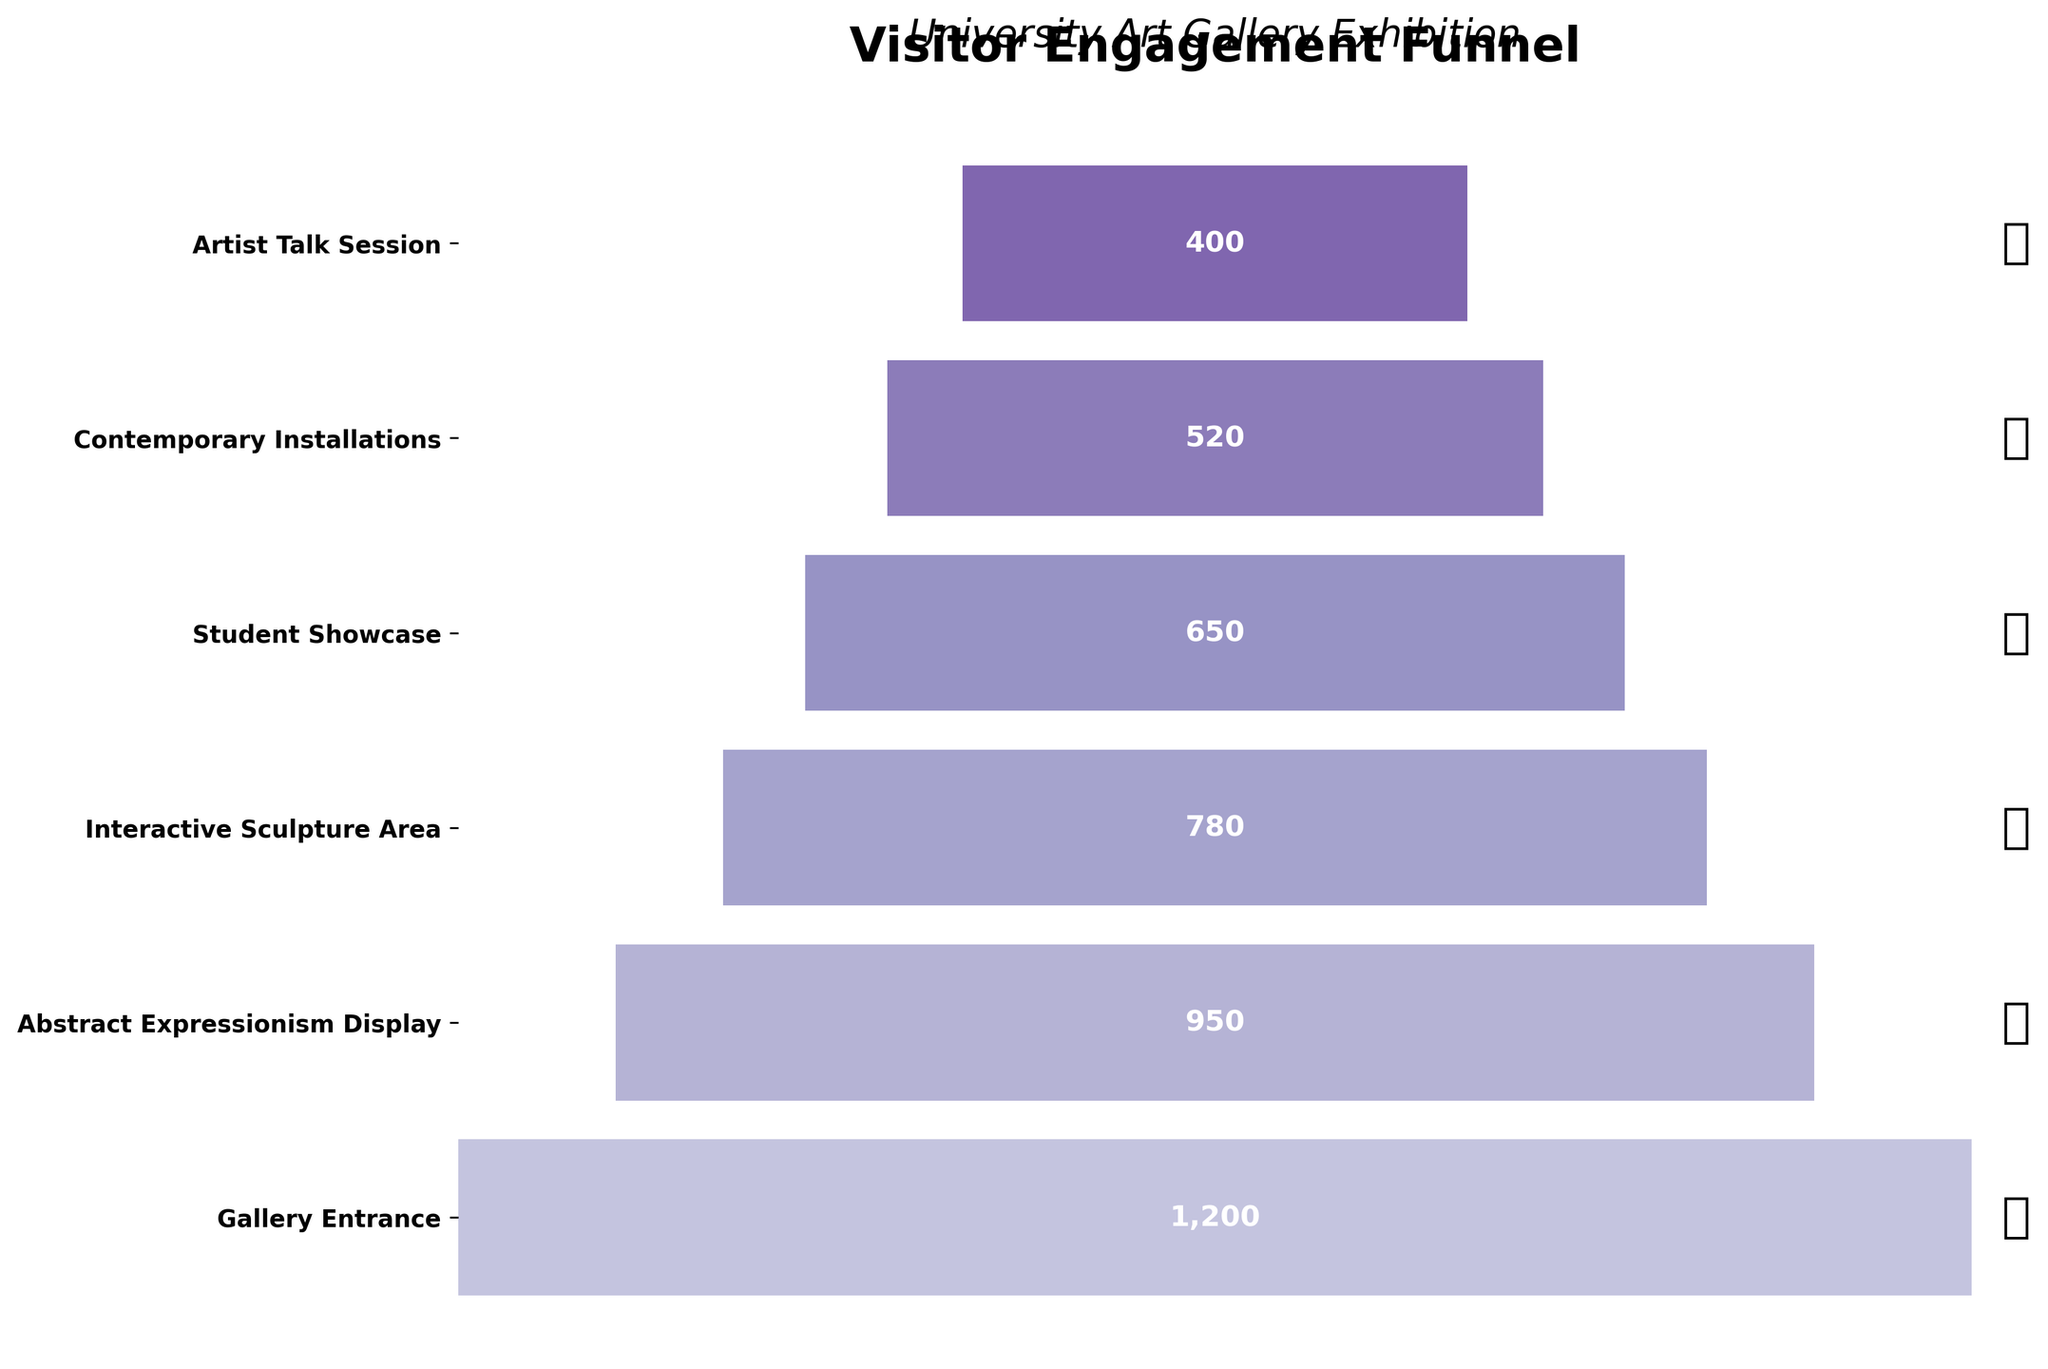What's the title of the figure? The title of the figure is displayed at the top and reads "Visitor Engagement Funnel." This is clearly at the center and above the funnel itself.
Answer: Visitor Engagement Funnel Which section has the highest number of visitors? By looking at the topmost and the widest part of the funnel, we can see the section name and the visitor count, which is "Gallery Entrance" with 1200 visitors.
Answer: Gallery Entrance Which section has the lowest number of visitors? By observing the narrowest, bottom-most section of the funnel, the section name and visitor count indicate "Artist Talk Session" with 400 visitors.
Answer: Artist Talk Session What is the difference in visitor numbers between the "Gallery Entrance" and "Contemporary Installations"? The "Gallery Entrance" has 1200 visitors, while "Contemporary Installations" has 520 visitors. The difference is calculated by subtracting 520 from 1200.
Answer: 680 Between which two sections is the drop in visitor numbers the largest? By comparing the differences in visitor numbers between consecutive sections, the largest drop is between the "Gallery Entrance" with 1200 visitors and the "Abstract Expressionism Display" with 950 visitors, a drop of 250 visitors, which is the largest compared to drops between other sections.
Answer: Gallery Entrance and Abstract Expressionism Display How many sections are there in total? By counting the number of horizontal bars (sections) in the funnel, we can see that there are six sections in total.
Answer: Six Which sections have visitor numbers greater than 700? The sections with visitor numbers greater than 700, as seen in the funnel, are "Gallery Entrance" (1200 visitors), "Abstract Expressionism Display" (950 visitors), and "Interactive Sculpture Area" (780 visitors).
Answer: Gallery Entrance, Abstract Expressionism Display, and Interactive Sculpture Area What is the average number of visitors across all sections? To find the average, sum up the visitor numbers across all sections and divide it by the total number of sections: (1200 + 950 + 780 + 650 + 520 + 400) / 6 = 4500 / 6 = 750
Answer: 750 Which sections have more than half the visitors compared to the "Gallery Entrance"? The "Gallery Entrance" has 1200 visitors, so half of 1200 is 600. The sections with more than 600 visitors are: "Abstract Expressionism Display" (950), "Interactive Sculpture Area" (780), "Student Showcase" (650), and "Contemporary Installations" (520 is not greater than 600, so it isn't included).
Answer: Abstract Expressionism Display, Interactive Sculpture Area, and Student Showcase 